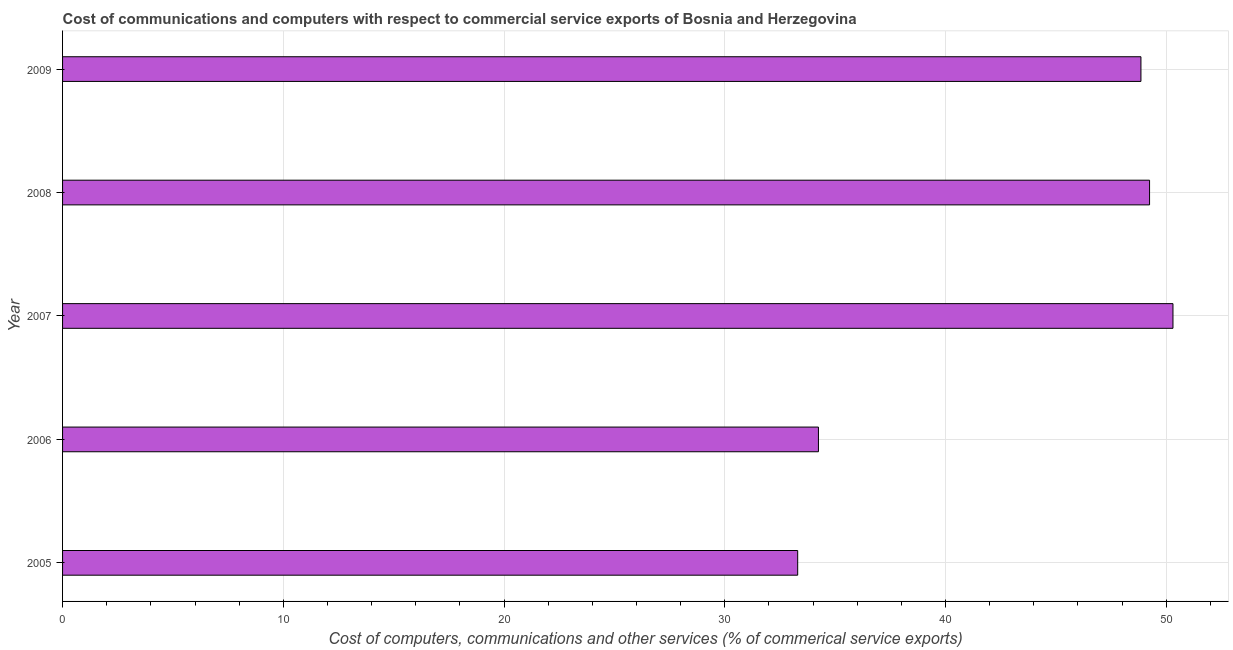Does the graph contain any zero values?
Provide a succinct answer. No. What is the title of the graph?
Offer a terse response. Cost of communications and computers with respect to commercial service exports of Bosnia and Herzegovina. What is the label or title of the X-axis?
Your response must be concise. Cost of computers, communications and other services (% of commerical service exports). What is the cost of communications in 2005?
Provide a short and direct response. 33.3. Across all years, what is the maximum cost of communications?
Your answer should be very brief. 50.3. Across all years, what is the minimum  computer and other services?
Your answer should be very brief. 33.3. In which year was the cost of communications maximum?
Provide a short and direct response. 2007. What is the sum of the cost of communications?
Keep it short and to the point. 215.95. What is the difference between the cost of communications in 2006 and 2008?
Give a very brief answer. -15. What is the average  computer and other services per year?
Keep it short and to the point. 43.19. What is the median  computer and other services?
Offer a very short reply. 48.85. In how many years, is the cost of communications greater than 22 %?
Your response must be concise. 5. What is the ratio of the  computer and other services in 2005 to that in 2007?
Your answer should be very brief. 0.66. Is the  computer and other services in 2007 less than that in 2008?
Make the answer very short. No. Is the difference between the cost of communications in 2008 and 2009 greater than the difference between any two years?
Offer a very short reply. No. What is the difference between the highest and the second highest cost of communications?
Offer a terse response. 1.06. Is the sum of the cost of communications in 2005 and 2006 greater than the maximum cost of communications across all years?
Provide a short and direct response. Yes. In how many years, is the cost of communications greater than the average cost of communications taken over all years?
Make the answer very short. 3. How many bars are there?
Offer a terse response. 5. Are all the bars in the graph horizontal?
Provide a succinct answer. Yes. How many years are there in the graph?
Your answer should be compact. 5. What is the difference between two consecutive major ticks on the X-axis?
Your answer should be compact. 10. Are the values on the major ticks of X-axis written in scientific E-notation?
Keep it short and to the point. No. What is the Cost of computers, communications and other services (% of commerical service exports) in 2005?
Your answer should be compact. 33.3. What is the Cost of computers, communications and other services (% of commerical service exports) of 2006?
Your answer should be very brief. 34.24. What is the Cost of computers, communications and other services (% of commerical service exports) of 2007?
Your answer should be compact. 50.3. What is the Cost of computers, communications and other services (% of commerical service exports) in 2008?
Offer a very short reply. 49.24. What is the Cost of computers, communications and other services (% of commerical service exports) of 2009?
Provide a short and direct response. 48.85. What is the difference between the Cost of computers, communications and other services (% of commerical service exports) in 2005 and 2006?
Your answer should be very brief. -0.94. What is the difference between the Cost of computers, communications and other services (% of commerical service exports) in 2005 and 2007?
Ensure brevity in your answer.  -17. What is the difference between the Cost of computers, communications and other services (% of commerical service exports) in 2005 and 2008?
Provide a short and direct response. -15.94. What is the difference between the Cost of computers, communications and other services (% of commerical service exports) in 2005 and 2009?
Offer a terse response. -15.55. What is the difference between the Cost of computers, communications and other services (% of commerical service exports) in 2006 and 2007?
Offer a very short reply. -16.06. What is the difference between the Cost of computers, communications and other services (% of commerical service exports) in 2006 and 2008?
Ensure brevity in your answer.  -15. What is the difference between the Cost of computers, communications and other services (% of commerical service exports) in 2006 and 2009?
Provide a succinct answer. -14.61. What is the difference between the Cost of computers, communications and other services (% of commerical service exports) in 2007 and 2008?
Keep it short and to the point. 1.06. What is the difference between the Cost of computers, communications and other services (% of commerical service exports) in 2007 and 2009?
Provide a short and direct response. 1.45. What is the difference between the Cost of computers, communications and other services (% of commerical service exports) in 2008 and 2009?
Provide a succinct answer. 0.39. What is the ratio of the Cost of computers, communications and other services (% of commerical service exports) in 2005 to that in 2007?
Provide a short and direct response. 0.66. What is the ratio of the Cost of computers, communications and other services (% of commerical service exports) in 2005 to that in 2008?
Your answer should be compact. 0.68. What is the ratio of the Cost of computers, communications and other services (% of commerical service exports) in 2005 to that in 2009?
Offer a very short reply. 0.68. What is the ratio of the Cost of computers, communications and other services (% of commerical service exports) in 2006 to that in 2007?
Offer a very short reply. 0.68. What is the ratio of the Cost of computers, communications and other services (% of commerical service exports) in 2006 to that in 2008?
Keep it short and to the point. 0.69. What is the ratio of the Cost of computers, communications and other services (% of commerical service exports) in 2006 to that in 2009?
Offer a very short reply. 0.7. What is the ratio of the Cost of computers, communications and other services (% of commerical service exports) in 2007 to that in 2009?
Keep it short and to the point. 1.03. What is the ratio of the Cost of computers, communications and other services (% of commerical service exports) in 2008 to that in 2009?
Make the answer very short. 1.01. 